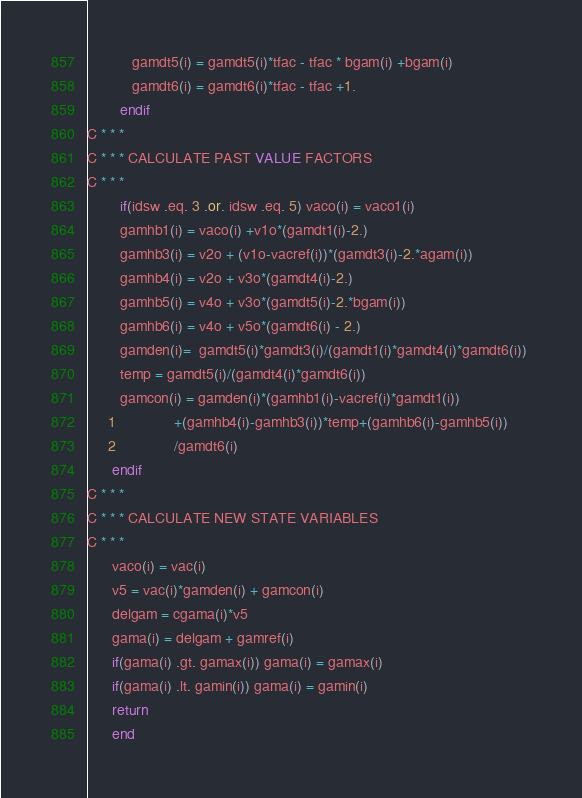Convert code to text. <code><loc_0><loc_0><loc_500><loc_500><_FORTRAN_>           gamdt5(i) = gamdt5(i)*tfac - tfac * bgam(i) +bgam(i)         
           gamdt6(i) = gamdt6(i)*tfac - tfac +1.                        
        endif                                                           
C * * *                                                                 
C * * * CALCULATE PAST VALUE FACTORS                                    
C * * *                                                                 
        if(idsw .eq. 3 .or. idsw .eq. 5) vaco(i) = vaco1(i)             
        gamhb1(i) = vaco(i) +v1o*(gamdt1(i)-2.)                         
        gamhb3(i) = v2o + (v1o-vacref(i))*(gamdt3(i)-2.*agam(i))        
        gamhb4(i) = v2o + v3o*(gamdt4(i)-2.)                            
        gamhb5(i) = v4o + v3o*(gamdt5(i)-2.*bgam(i))                    
        gamhb6(i) = v4o + v5o*(gamdt6(i) - 2.)                          
        gamden(i)=  gamdt5(i)*gamdt3(i)/(gamdt1(i)*gamdt4(i)*gamdt6(i)) 
        temp = gamdt5(i)/(gamdt4(i)*gamdt6(i))                          
        gamcon(i) = gamden(i)*(gamhb1(i)-vacref(i)*gamdt1(i))           
     1              +(gamhb4(i)-gamhb3(i))*temp+(gamhb6(i)-gamhb5(i))   
     2              /gamdt6(i)                                          
      endif                                                             
C * * *                                                                 
C * * * CALCULATE NEW STATE VARIABLES                                   
C * * *                                                                 
      vaco(i) = vac(i)                                                  
      v5 = vac(i)*gamden(i) + gamcon(i)                                 
      delgam = cgama(i)*v5                                              
      gama(i) = delgam + gamref(i)                                      
      if(gama(i) .gt. gamax(i)) gama(i) = gamax(i)                      
      if(gama(i) .lt. gamin(i)) gama(i) = gamin(i)                      
      return                                                            
      end                                                               
</code> 